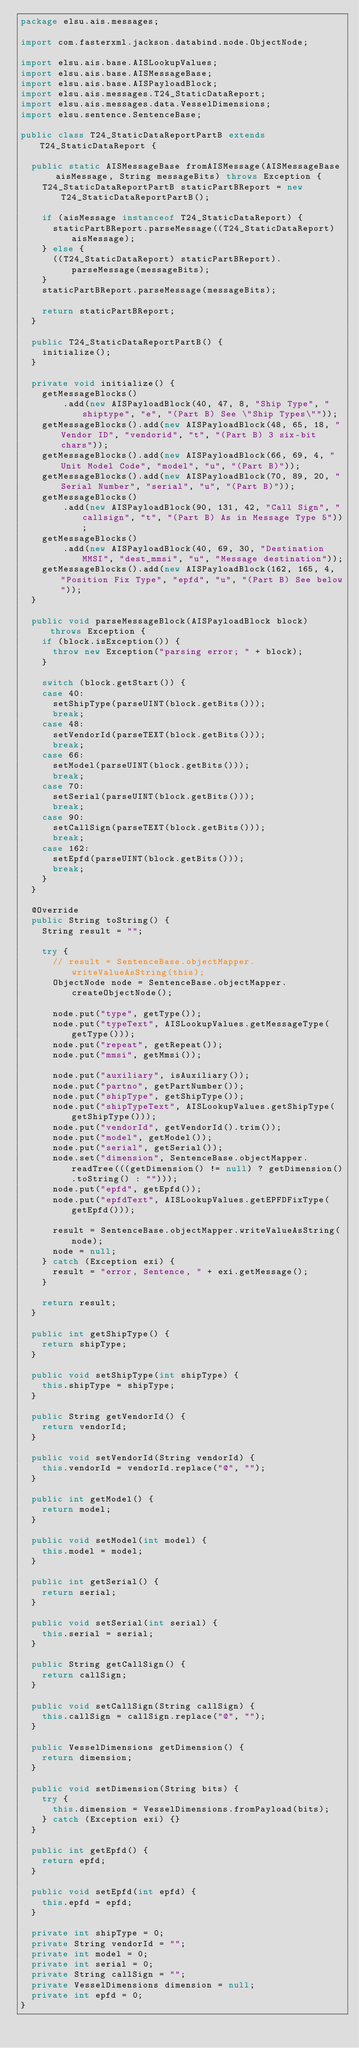Convert code to text. <code><loc_0><loc_0><loc_500><loc_500><_Java_>package elsu.ais.messages;

import com.fasterxml.jackson.databind.node.ObjectNode;

import elsu.ais.base.AISLookupValues;
import elsu.ais.base.AISMessageBase;
import elsu.ais.base.AISPayloadBlock;
import elsu.ais.messages.T24_StaticDataReport;
import elsu.ais.messages.data.VesselDimensions;
import elsu.sentence.SentenceBase;

public class T24_StaticDataReportPartB extends T24_StaticDataReport {

	public static AISMessageBase fromAISMessage(AISMessageBase aisMessage, String messageBits) throws Exception {
		T24_StaticDataReportPartB staticPartBReport = new T24_StaticDataReportPartB();

		if (aisMessage instanceof T24_StaticDataReport) {
			staticPartBReport.parseMessage((T24_StaticDataReport) aisMessage);
		} else {
			((T24_StaticDataReport) staticPartBReport).parseMessage(messageBits);
		}
		staticPartBReport.parseMessage(messageBits);

		return staticPartBReport;
	}

	public T24_StaticDataReportPartB() {
		initialize();
	}

	private void initialize() {
		getMessageBlocks()
				.add(new AISPayloadBlock(40, 47, 8, "Ship Type", "shiptype", "e", "(Part B) See \"Ship Types\""));
		getMessageBlocks().add(new AISPayloadBlock(48, 65, 18, "Vendor ID", "vendorid", "t", "(Part B) 3 six-bit chars"));
		getMessageBlocks().add(new AISPayloadBlock(66, 69, 4, "Unit Model Code", "model", "u", "(Part B)"));
		getMessageBlocks().add(new AISPayloadBlock(70, 89, 20, "Serial Number", "serial", "u", "(Part B)"));
		getMessageBlocks()
				.add(new AISPayloadBlock(90, 131, 42, "Call Sign", "callsign", "t", "(Part B) As in Message Type 5"));
		getMessageBlocks()
				.add(new AISPayloadBlock(40, 69, 30, "Destination MMSI", "dest_mmsi", "u", "Message destination"));
		getMessageBlocks().add(new AISPayloadBlock(162, 165, 4, "Position Fix Type", "epfd", "u", "(Part B) See below"));
	}

	public void parseMessageBlock(AISPayloadBlock block) throws Exception {
		if (block.isException()) {
			throw new Exception("parsing error; " + block);
		}

		switch (block.getStart()) {
		case 40:
			setShipType(parseUINT(block.getBits()));
			break;
		case 48:
			setVendorId(parseTEXT(block.getBits()));
			break;
		case 66:
			setModel(parseUINT(block.getBits()));
			break;
		case 70:
			setSerial(parseUINT(block.getBits()));
			break;
		case 90:
			setCallSign(parseTEXT(block.getBits()));
			break;
		case 162:
			setEpfd(parseUINT(block.getBits()));
			break;
		}
	}

	@Override
	public String toString() {
		String result = "";
		
		try {
			// result = SentenceBase.objectMapper.writeValueAsString(this);
			ObjectNode node = SentenceBase.objectMapper.createObjectNode();

			node.put("type", getType());
			node.put("typeText", AISLookupValues.getMessageType(getType()));
			node.put("repeat", getRepeat());
			node.put("mmsi", getMmsi());
			
			node.put("auxiliary", isAuxiliary());
			node.put("partno", getPartNumber());
			node.put("shipType", getShipType());
			node.put("shipTypeText", AISLookupValues.getShipType(getShipType()));
			node.put("vendorId", getVendorId().trim());
			node.put("model", getModel());
			node.put("serial", getSerial());
			node.set("dimension", SentenceBase.objectMapper.readTree(((getDimension() != null) ? getDimension().toString() : "")));
			node.put("epfd", getEpfd());
			node.put("epfdText", AISLookupValues.getEPFDFixType(getEpfd()));

			result = SentenceBase.objectMapper.writeValueAsString(node);
			node = null;
		} catch (Exception exi) {
			result = "error, Sentence, " + exi.getMessage();
		}
		
		return result;
	}

	public int getShipType() {
		return shipType;
	}

	public void setShipType(int shipType) {
		this.shipType = shipType;
	}

	public String getVendorId() {
		return vendorId;
	}

	public void setVendorId(String vendorId) {
		this.vendorId = vendorId.replace("@", "");
	}

	public int getModel() {
		return model;
	}

	public void setModel(int model) {
		this.model = model;
	}

	public int getSerial() {
		return serial;
	}

	public void setSerial(int serial) {
		this.serial = serial;
	}

	public String getCallSign() {
		return callSign;
	}

	public void setCallSign(String callSign) {
		this.callSign = callSign.replace("@", "");
	}

	public VesselDimensions getDimension() {
		return dimension;
	}

	public void setDimension(String bits) {
		try {
			this.dimension = VesselDimensions.fromPayload(bits);
		} catch (Exception exi) {}
	}

	public int getEpfd() {
		return epfd;
	}

	public void setEpfd(int epfd) {
		this.epfd = epfd;
	}

	private int shipType = 0;
	private String vendorId = "";
	private int model = 0;
	private int serial = 0;
	private String callSign = "";
	private VesselDimensions dimension = null;
	private int epfd = 0;
}
</code> 